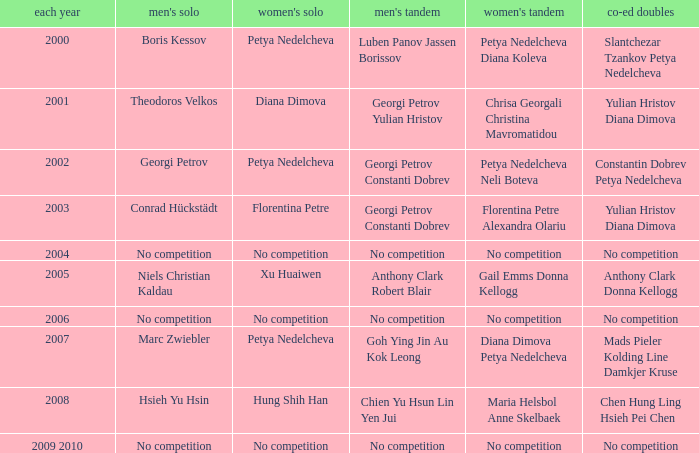Parse the full table. {'header': ['each year', "men's solo", "women's solo", "men's tandem", "women's tandem", 'co-ed doubles'], 'rows': [['2000', 'Boris Kessov', 'Petya Nedelcheva', 'Luben Panov Jassen Borissov', 'Petya Nedelcheva Diana Koleva', 'Slantchezar Tzankov Petya Nedelcheva'], ['2001', 'Theodoros Velkos', 'Diana Dimova', 'Georgi Petrov Yulian Hristov', 'Chrisa Georgali Christina Mavromatidou', 'Yulian Hristov Diana Dimova'], ['2002', 'Georgi Petrov', 'Petya Nedelcheva', 'Georgi Petrov Constanti Dobrev', 'Petya Nedelcheva Neli Boteva', 'Constantin Dobrev Petya Nedelcheva'], ['2003', 'Conrad Hückstädt', 'Florentina Petre', 'Georgi Petrov Constanti Dobrev', 'Florentina Petre Alexandra Olariu', 'Yulian Hristov Diana Dimova'], ['2004', 'No competition', 'No competition', 'No competition', 'No competition', 'No competition'], ['2005', 'Niels Christian Kaldau', 'Xu Huaiwen', 'Anthony Clark Robert Blair', 'Gail Emms Donna Kellogg', 'Anthony Clark Donna Kellogg'], ['2006', 'No competition', 'No competition', 'No competition', 'No competition', 'No competition'], ['2007', 'Marc Zwiebler', 'Petya Nedelcheva', 'Goh Ying Jin Au Kok Leong', 'Diana Dimova Petya Nedelcheva', 'Mads Pieler Kolding Line Damkjer Kruse'], ['2008', 'Hsieh Yu Hsin', 'Hung Shih Han', 'Chien Yu Hsun Lin Yen Jui', 'Maria Helsbol Anne Skelbaek', 'Chen Hung Ling Hsieh Pei Chen'], ['2009 2010', 'No competition', 'No competition', 'No competition', 'No competition', 'No competition']]} In what year was there no competition for women? 2004, 2006, 2009 2010. 